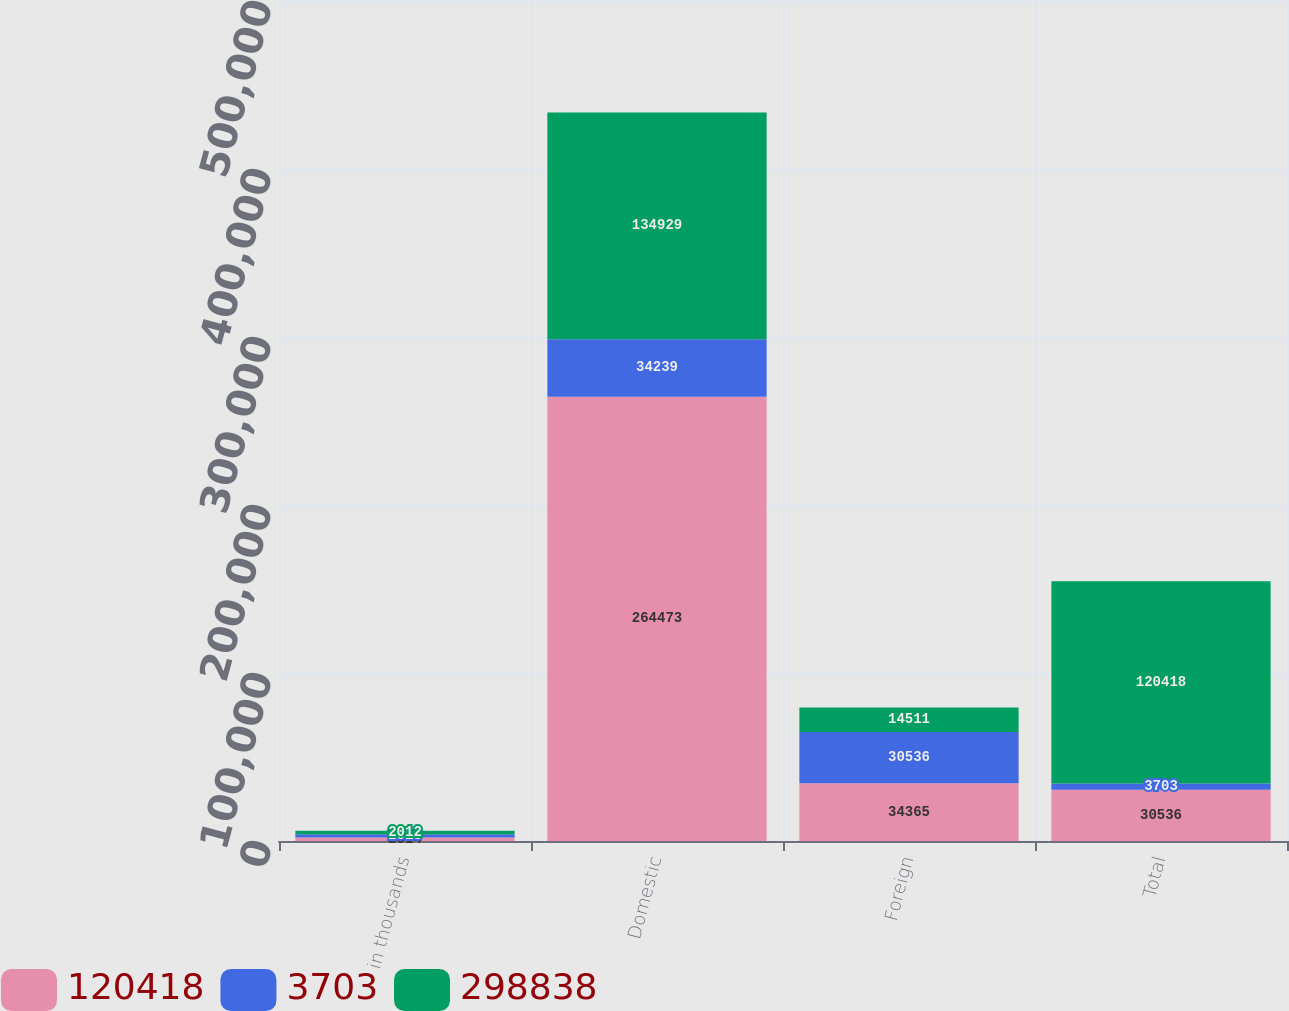Convert chart. <chart><loc_0><loc_0><loc_500><loc_500><stacked_bar_chart><ecel><fcel>in thousands<fcel>Domestic<fcel>Foreign<fcel>Total<nl><fcel>120418<fcel>2014<fcel>264473<fcel>34365<fcel>30536<nl><fcel>3703<fcel>2013<fcel>34239<fcel>30536<fcel>3703<nl><fcel>298838<fcel>2012<fcel>134929<fcel>14511<fcel>120418<nl></chart> 